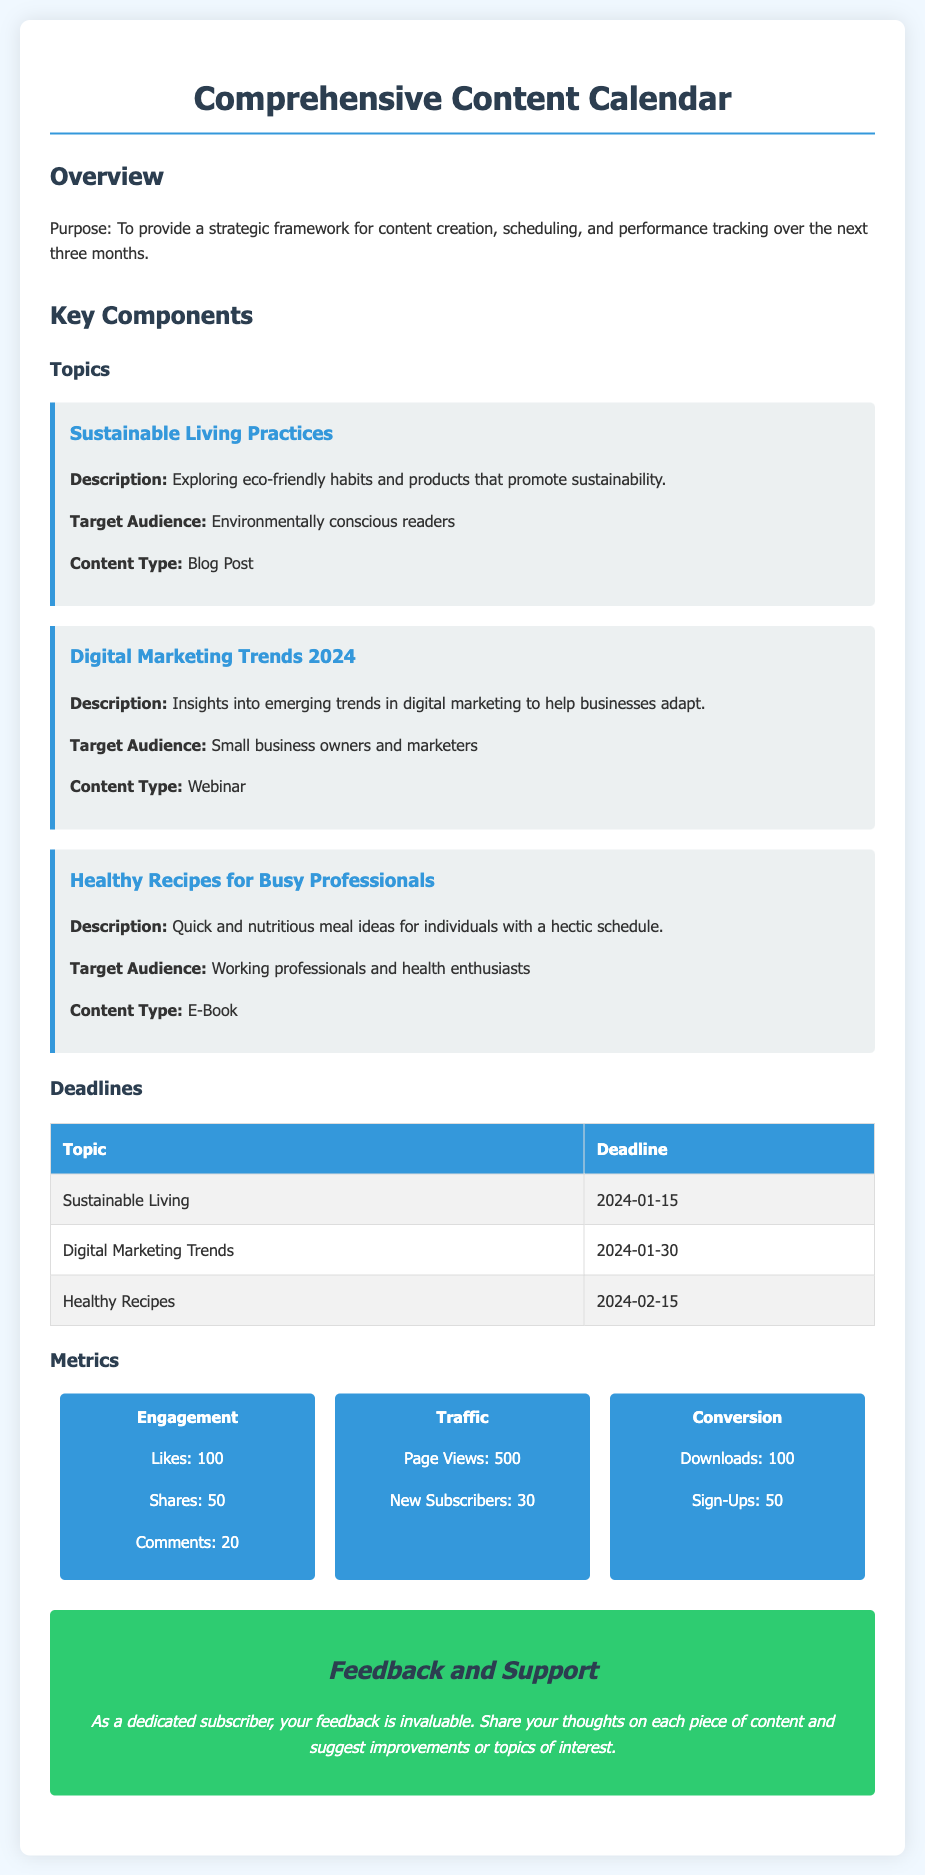What is the purpose of the content calendar? The purpose is to provide a strategic framework for content creation, scheduling, and performance tracking over the next three months.
Answer: To provide a strategic framework for content creation, scheduling, and performance tracking over the next three months What is the first topic listed in the content calendar? The first topic is titled "Sustainable Living Practices."
Answer: Sustainable Living Practices What is the deadline for the "Digital Marketing Trends" topic? The deadline is specifically listed in the deadlines table.
Answer: 2024-01-30 How many metrics are listed in the document? There are three metrics presented in the metrics section: Engagement, Traffic, and Conversion.
Answer: 3 What is the target audience for "Healthy Recipes for Busy Professionals"? The target audience is clearly stated in the description of the topic.
Answer: Working professionals and health enthusiasts How many likes are recorded under the Engagement metric? The number of likes is provided specifically under the Engagement metric.
Answer: 100 What type of content is associated with "Digital Marketing Trends 2024"? The content type can be found in the topic description.
Answer: Webinar What is included in the feedback and support section? The feedback section encourages sharing thoughts and suggesting improvements.
Answer: Share your thoughts on each piece of content and suggest improvements or topics of interest 